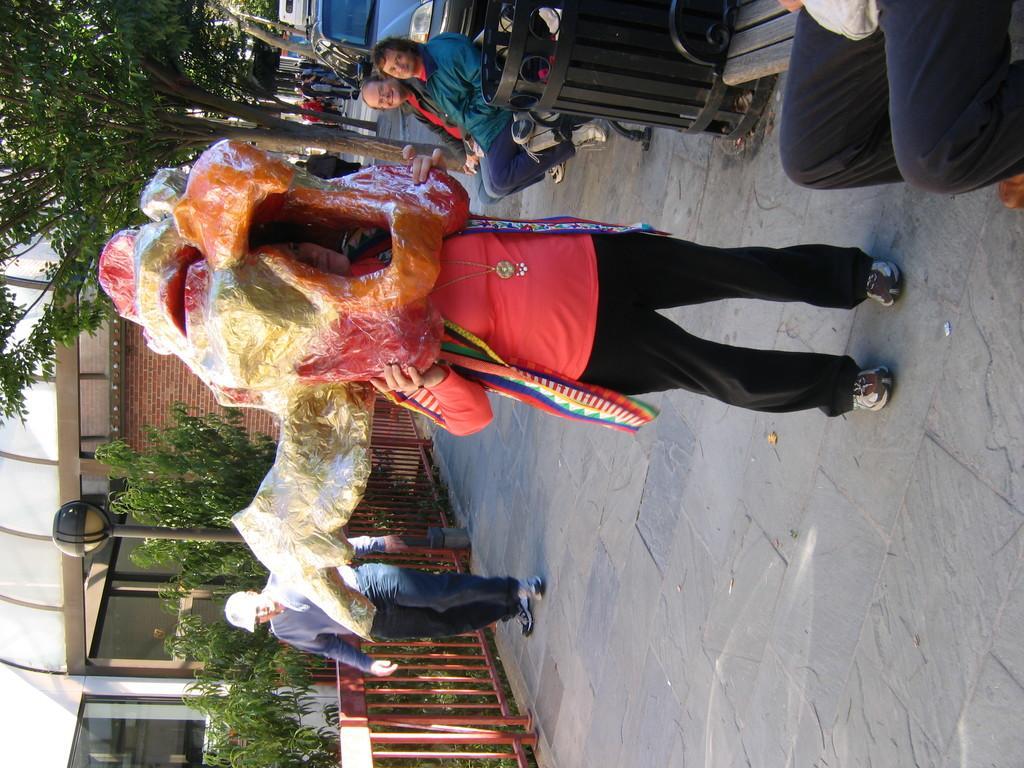Could you give a brief overview of what you see in this image? This picture we can observe a person standing on the floor, wearing a mask on the head which is looking big. There are some people sitting on the benches. We can observe a person here. There is a railing beside him. In the background there are trees, street light pole and a building. 